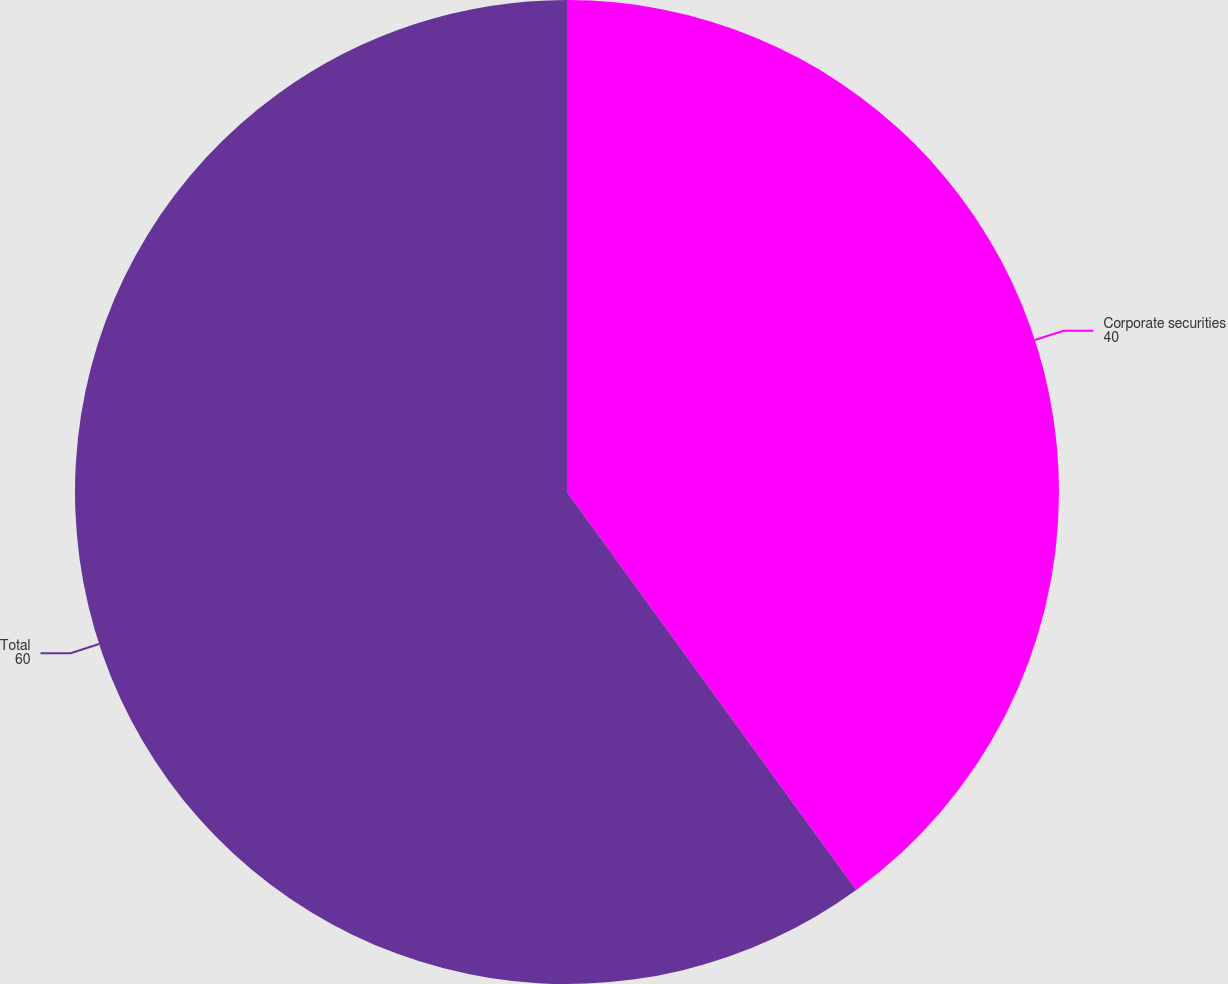Convert chart to OTSL. <chart><loc_0><loc_0><loc_500><loc_500><pie_chart><fcel>Corporate securities<fcel>Total<nl><fcel>40.0%<fcel>60.0%<nl></chart> 